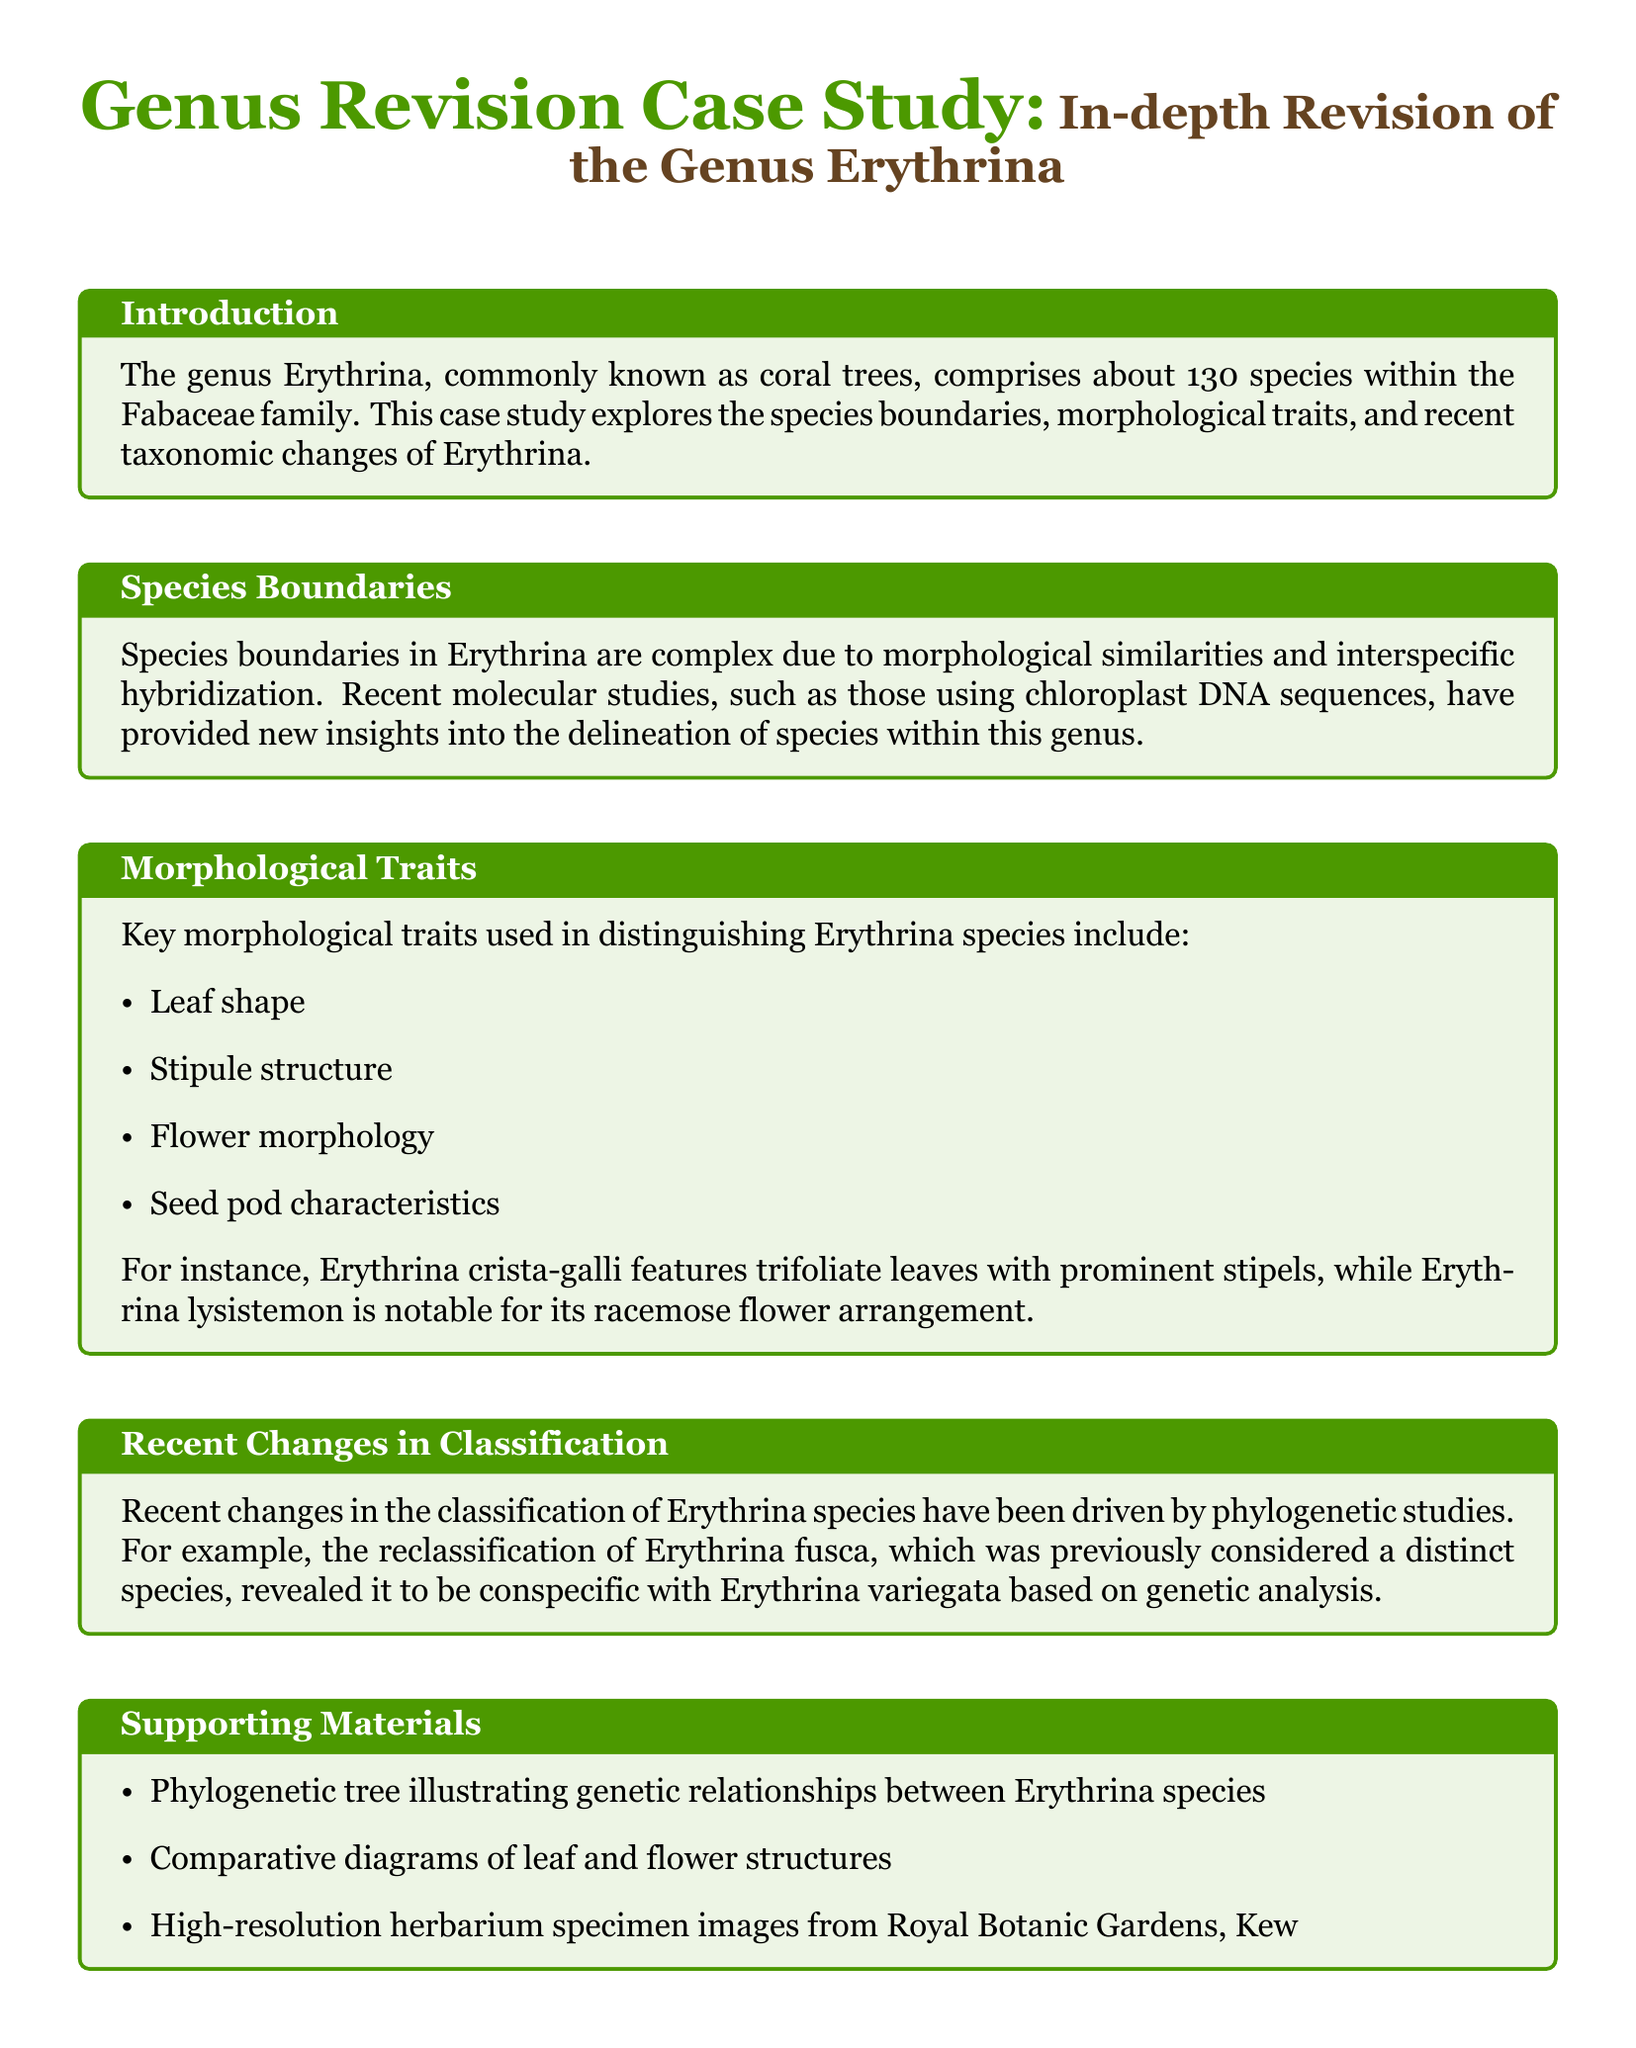What is the total number of species in the genus Erythrina? The genus Erythrina comprises about 130 species as stated in the introduction section of the document.
Answer: 130 What family does the genus Erythrina belong to? The document mentions that Erythrina is part of the Fabaceae family.
Answer: Fabaceae What key morphological trait is used to distinguish Erythrina species related to the structure of leaves? The document lists leaf shape as one of the key morphological traits used in distinguishing Erythrina species.
Answer: Leaf shape What is the name of the Erythrina species that features trifoliate leaves with prominent stipels? The document explicitly states that Erythrina crista-galli features trifoliate leaves with prominent stipels.
Answer: Erythrina crista-galli Which Erythrina species was revealed to be conspecific with Erythrina variegata? The reclassification of Erythrina fusca was revealed through genetic analysis in recent changes in classification.
Answer: Erythrina fusca What type of diagrams are included as supporting materials in the document? The supporting materials section mentions comparative diagrams of leaf and flower structures.
Answer: Comparative diagrams What type of analysis is emphasized for resolving taxonomic ambiguities in the conclusion? The conclusion underscores the integration of molecular data with traditional morphological analysis for resolving taxonomic ambiguities.
Answer: Molecular data and traditional morphological analysis What institution provided herbarium specimen images mentioned in the supporting materials? The document states that the herbarium specimen images are from the Royal Botanic Gardens, Kew.
Answer: Royal Botanic Gardens, Kew 